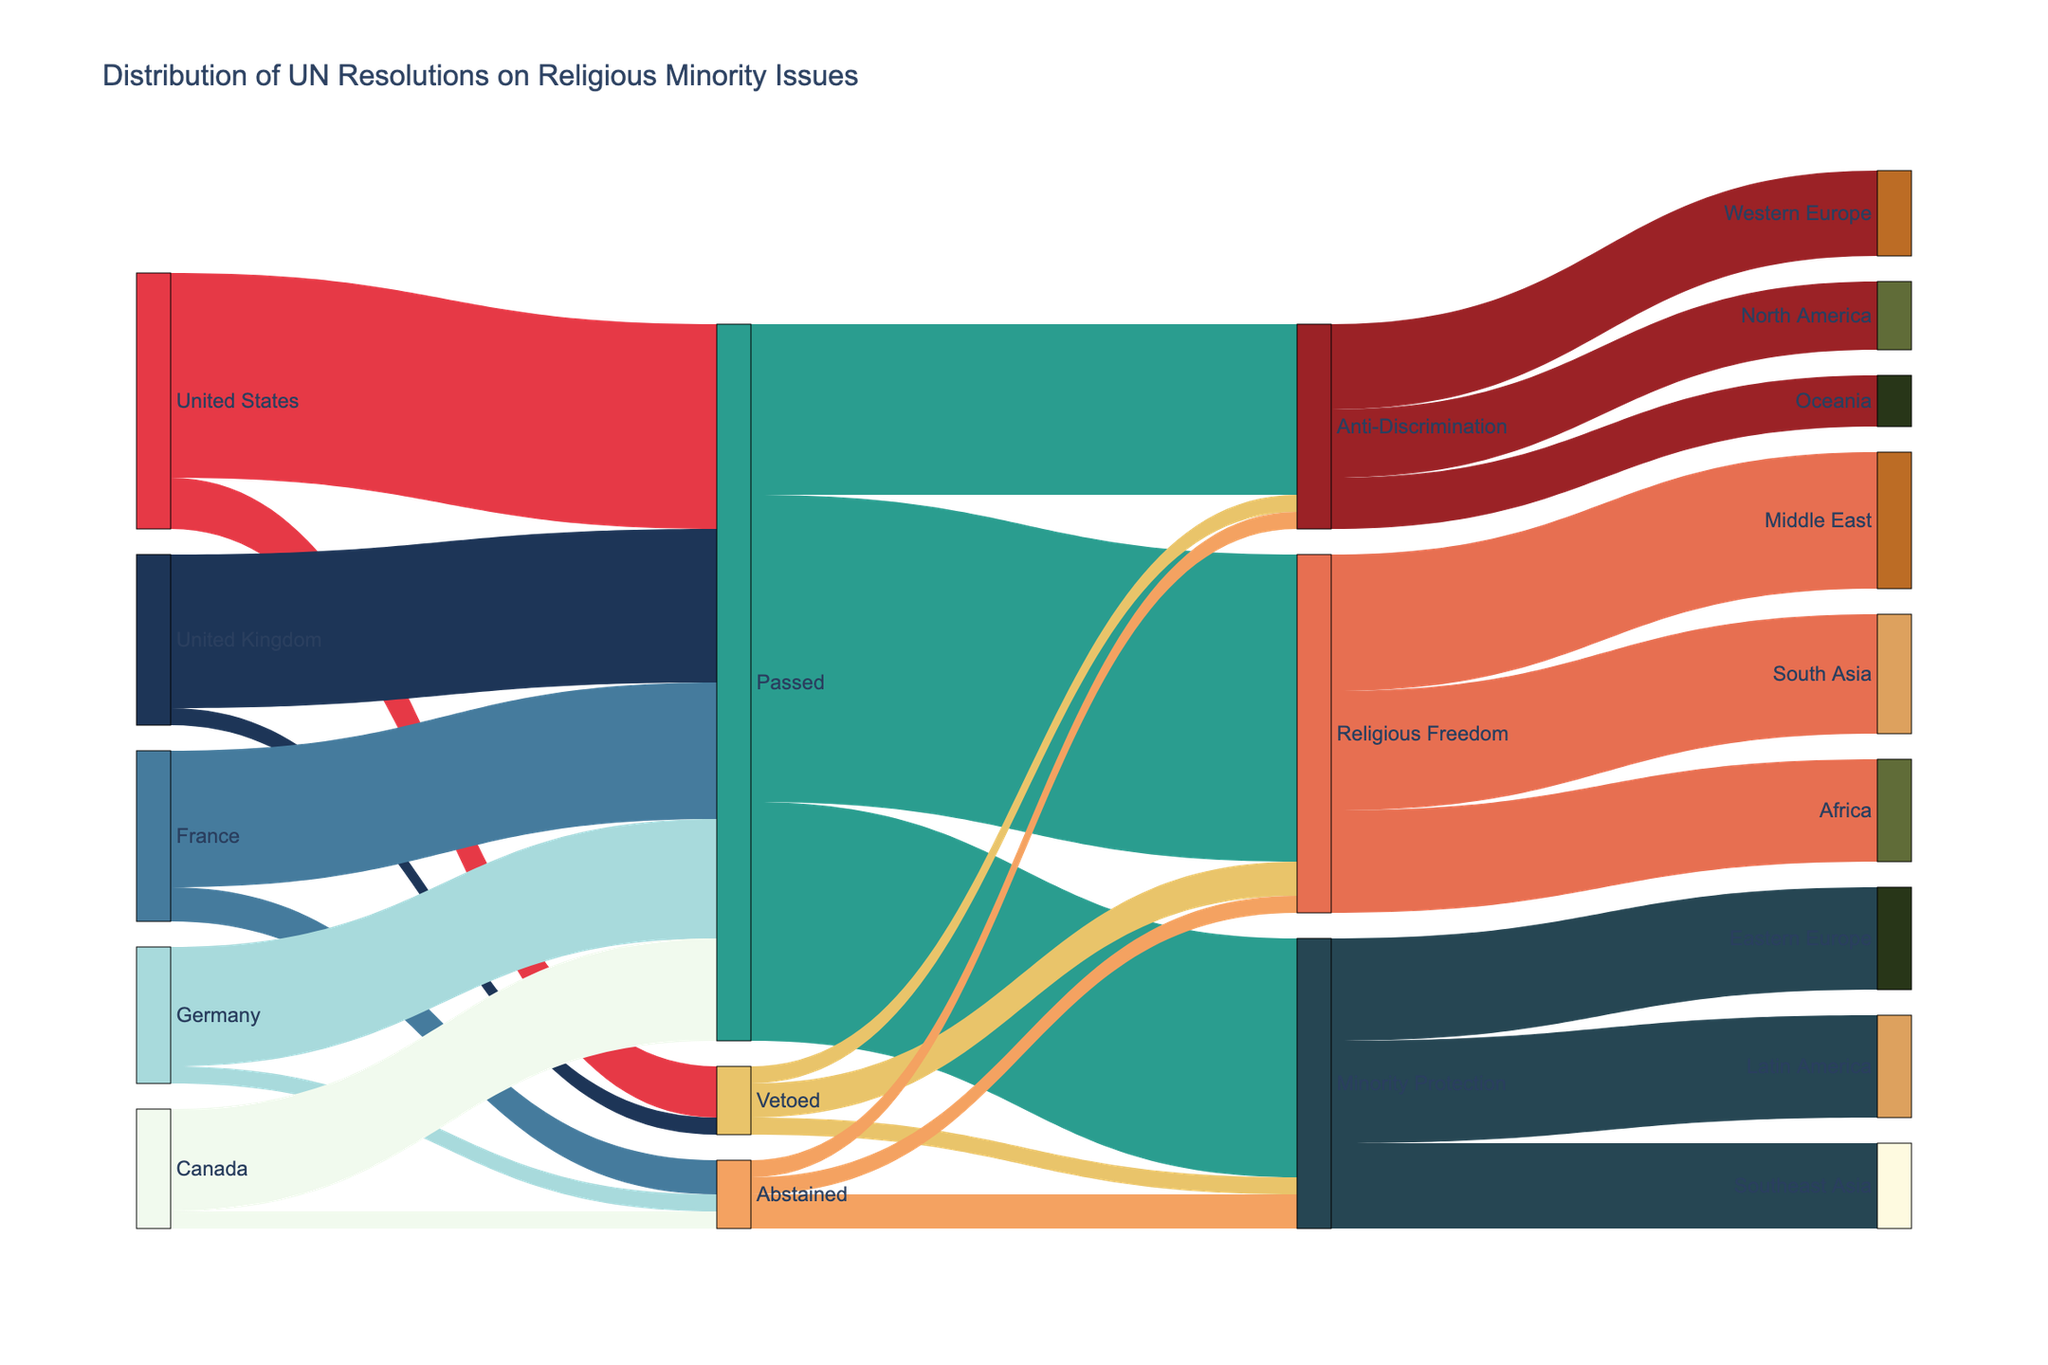What is the title of the Sankey Diagram? The title is usually displayed at the top of the diagram to describe what the visualization is about. By reading the title, the main topic of the chart can be understood.
Answer: Distribution of UN Resolutions on Religious Minority Issues Which sponsor nation has the highest number of vetoed resolutions? To find this, look at the links originating from different nations and targeting the 'Vetoed' node, then identify the nation with the highest link value.
Answer: United States How many resolutions were passed addressing Religious Freedom? Follow the link from the 'Passed' node to the 'Religious Freedom' node and find the value of that link.
Answer: 18 How many resolutions did Germany sponsor in total? Add up the values of all outbound links from Germany to determine the total number. Germany has links with 'Passed' (7) and 'Abstained' (1).
Answer: 8 Compare the number of resolutions passed by the United Kingdom and France. Which country sponsored more? Look at the links originating from the United Kingdom and France targeting the 'Passed' node, then compare their values. The UK has 9, and France has 8.
Answer: United Kingdom Combine the resolutions on Minority Protection and Anti-Discrimination passed by all sponsor nations. What is the total number? Add up the values from the 'Passed' node to the 'Minority Protection' node (14) and 'Anti-Discrimination' node (10). Summing these gives the total.
Answer: 24 How many total resolutions were abstained by Canada and Germany? Sum the links from Canada (1) and Germany (1) to the 'Abstained' node.
Answer: 2 Identify the region that received the most resolutions on Religious Freedom. Track all links from 'Religious Freedom' to various regions and identify the one with the highest value. The Middle East has 8, South Asia 7, and Africa 6.
Answer: Middle East Which type of issue had the least number of resolutions vetoed? Follow links from 'Vetoed' to issue types and compare values. Anti-Discrimination has the least with 1.
Answer: Anti-Discrimination Determine the total number of resolutions that focused on Africa and Latin America combined. Sum the values targeting Africa (Religious Freedom: 6) and Latin America (Minority Protection: 6).
Answer: 12 